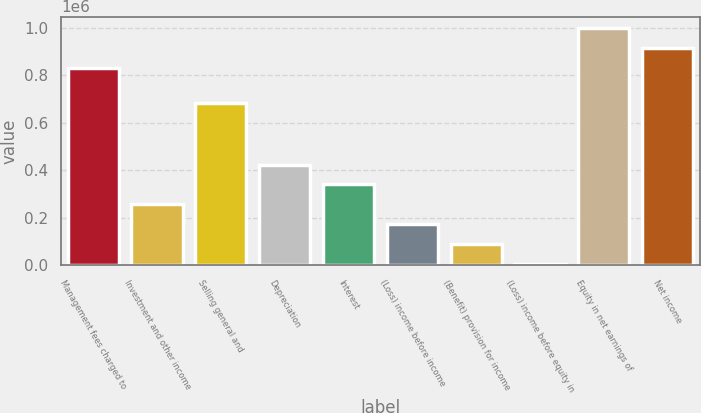Convert chart. <chart><loc_0><loc_0><loc_500><loc_500><bar_chart><fcel>Management fees charged to<fcel>Investment and other income<fcel>Selling general and<fcel>Depreciation<fcel>Interest<fcel>(Loss) income before income<fcel>(Benefit) provision for income<fcel>(Loss) income before equity in<fcel>Equity in net earnings of<fcel>Net income<nl><fcel>829515<fcel>255980<fcel>683562<fcel>422717<fcel>339349<fcel>172612<fcel>89243.4<fcel>5875<fcel>996252<fcel>912883<nl></chart> 